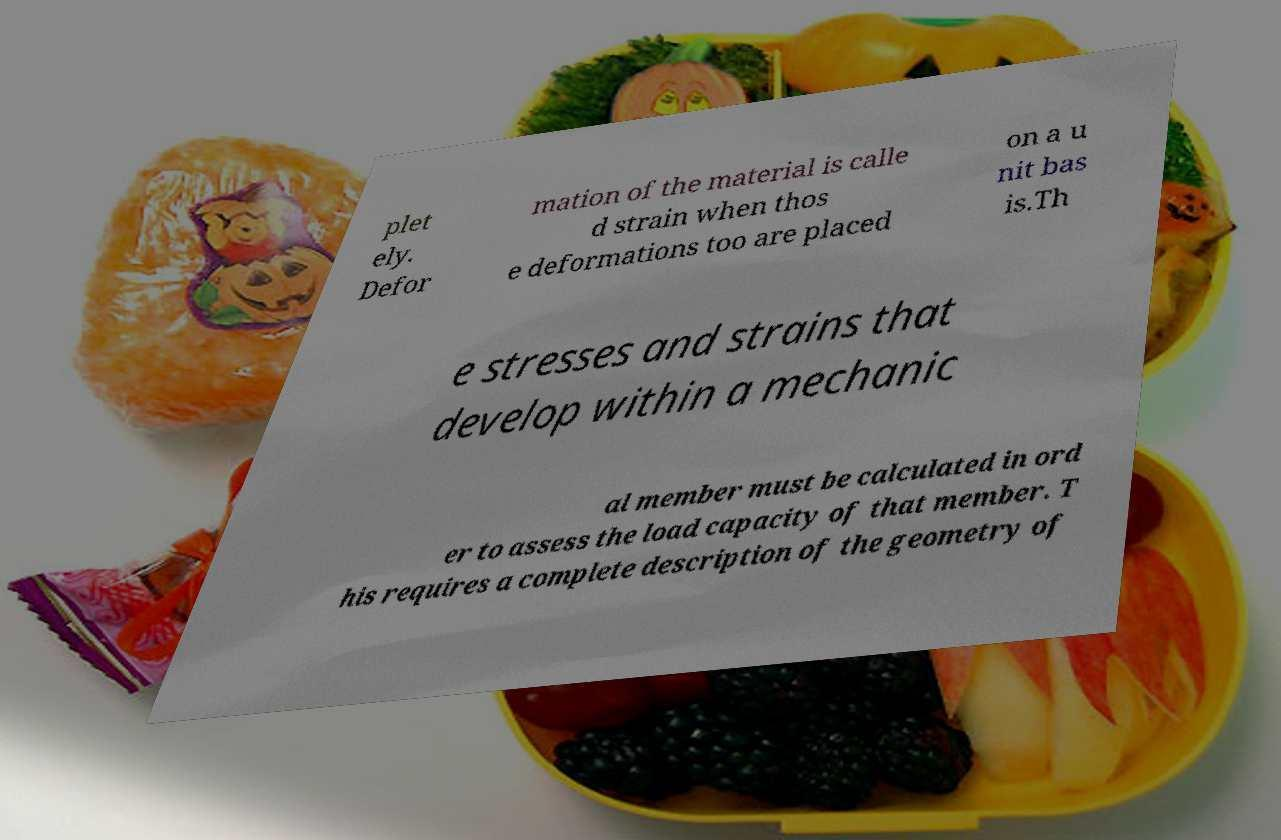For documentation purposes, I need the text within this image transcribed. Could you provide that? plet ely. Defor mation of the material is calle d strain when thos e deformations too are placed on a u nit bas is.Th e stresses and strains that develop within a mechanic al member must be calculated in ord er to assess the load capacity of that member. T his requires a complete description of the geometry of 